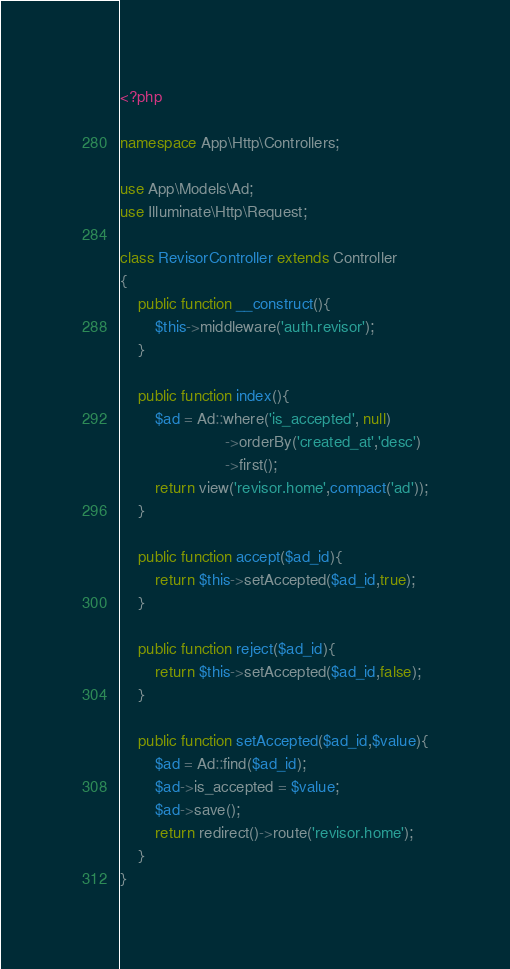Convert code to text. <code><loc_0><loc_0><loc_500><loc_500><_PHP_><?php

namespace App\Http\Controllers;

use App\Models\Ad;
use Illuminate\Http\Request;

class RevisorController extends Controller
{
    public function __construct(){
        $this->middleware('auth.revisor');
    }

    public function index(){
        $ad = Ad::where('is_accepted', null)
                        ->orderBy('created_at','desc')
                        ->first();
        return view('revisor.home',compact('ad'));
    }

    public function accept($ad_id){
        return $this->setAccepted($ad_id,true);
    }

    public function reject($ad_id){
        return $this->setAccepted($ad_id,false);
    }

    public function setAccepted($ad_id,$value){
        $ad = Ad::find($ad_id);
        $ad->is_accepted = $value;
        $ad->save();
        return redirect()->route('revisor.home');
    }
}
</code> 